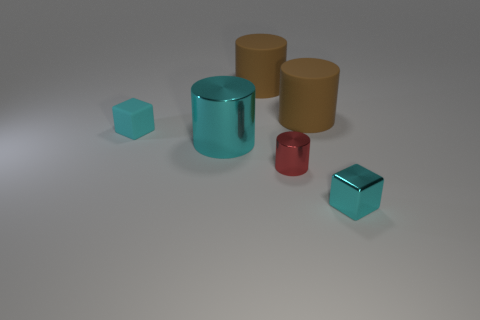There is another cyan block that is the same size as the cyan rubber cube; what material is it? Based on the image, the other cyan block with the same size as the cyan rubber cube appears to be made of a glossy plastic material, characterized by its shiny surface and clear reflections. 